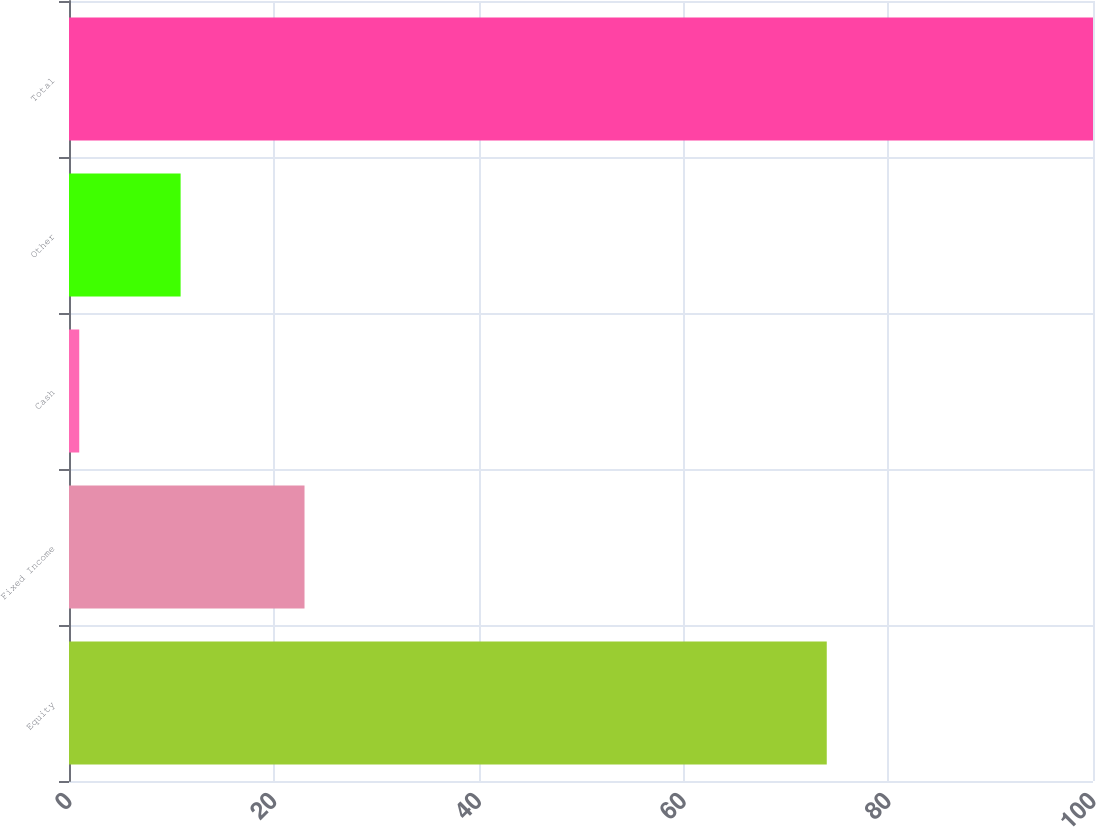<chart> <loc_0><loc_0><loc_500><loc_500><bar_chart><fcel>Equity<fcel>Fixed Income<fcel>Cash<fcel>Other<fcel>Total<nl><fcel>74<fcel>23<fcel>1<fcel>10.9<fcel>100<nl></chart> 